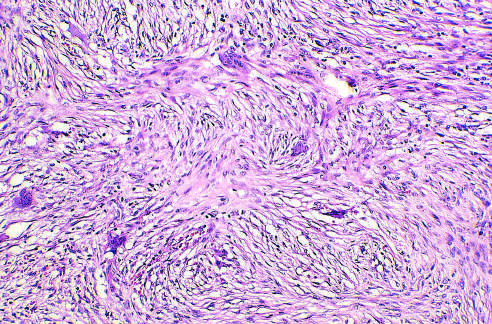what is fibrous dysplasia composed of?
Answer the question using a single word or phrase. Curvilinear trabeculae of woven bone 